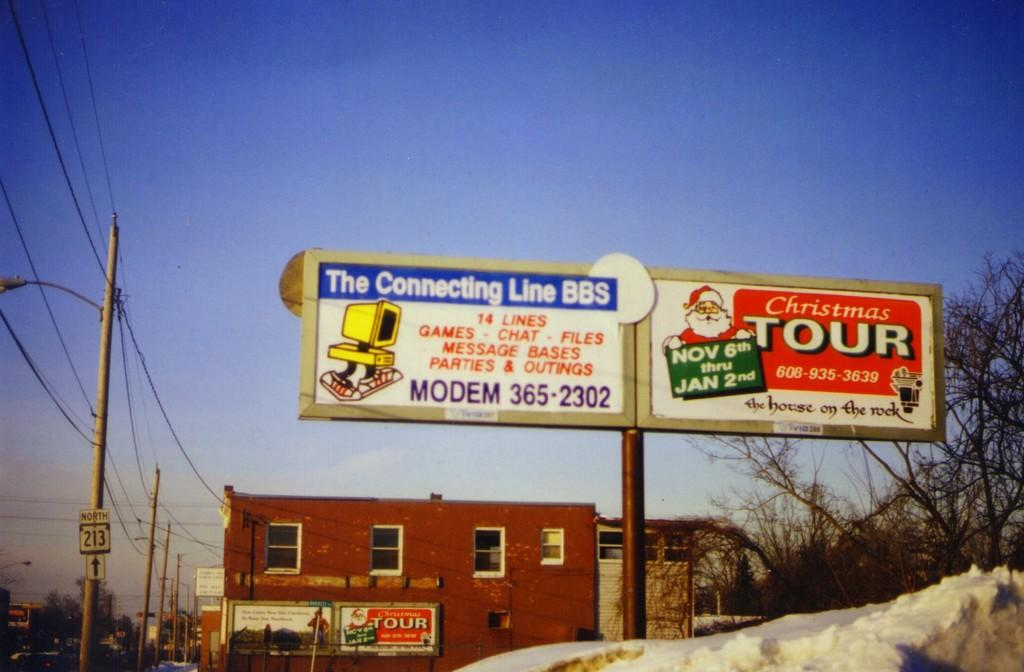<image>
Present a compact description of the photo's key features. A billboard tells that the Christmas Tour is starting on November 6th. 